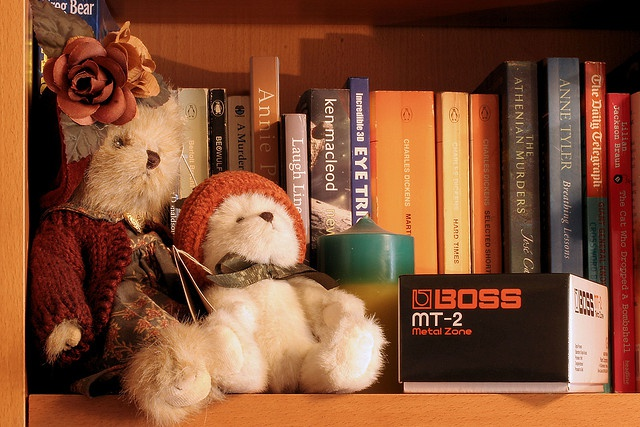Describe the objects in this image and their specific colors. I can see teddy bear in red, maroon, black, tan, and brown tones, teddy bear in red, tan, and lightgray tones, book in red, orange, and brown tones, book in red, gray, and black tones, and book in red, black, maroon, and brown tones in this image. 